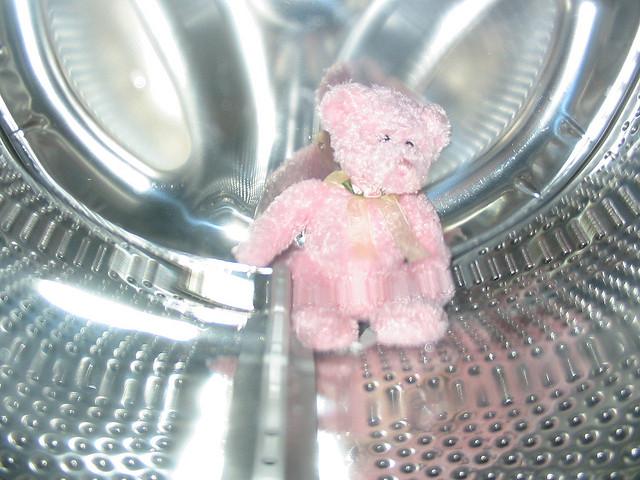What color is the bear?
Give a very brief answer. Pink. Which arm is higher than the other?
Be succinct. Right. Where is the bear sitting?
Keep it brief. Dryer. Why is the bear in the washing machine?
Give a very brief answer. Dirty. 